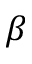Convert formula to latex. <formula><loc_0><loc_0><loc_500><loc_500>\beta</formula> 